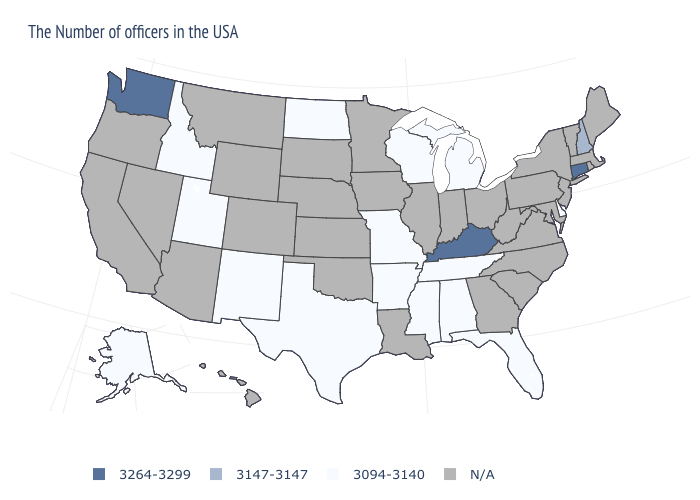What is the value of Montana?
Write a very short answer. N/A. Which states have the highest value in the USA?
Quick response, please. Connecticut, Kentucky, Washington. What is the value of Pennsylvania?
Answer briefly. N/A. Which states have the lowest value in the Northeast?
Give a very brief answer. New Hampshire. Which states have the lowest value in the USA?
Be succinct. Delaware, Florida, Michigan, Alabama, Tennessee, Wisconsin, Mississippi, Missouri, Arkansas, Texas, North Dakota, New Mexico, Utah, Idaho, Alaska. Does the map have missing data?
Keep it brief. Yes. Does Utah have the highest value in the USA?
Concise answer only. No. Name the states that have a value in the range 3147-3147?
Be succinct. New Hampshire. Name the states that have a value in the range N/A?
Give a very brief answer. Maine, Massachusetts, Rhode Island, Vermont, New York, New Jersey, Maryland, Pennsylvania, Virginia, North Carolina, South Carolina, West Virginia, Ohio, Georgia, Indiana, Illinois, Louisiana, Minnesota, Iowa, Kansas, Nebraska, Oklahoma, South Dakota, Wyoming, Colorado, Montana, Arizona, Nevada, California, Oregon, Hawaii. What is the value of Alabama?
Be succinct. 3094-3140. Name the states that have a value in the range 3147-3147?
Short answer required. New Hampshire. Does Wisconsin have the highest value in the USA?
Quick response, please. No. Does Kentucky have the lowest value in the South?
Short answer required. No. 